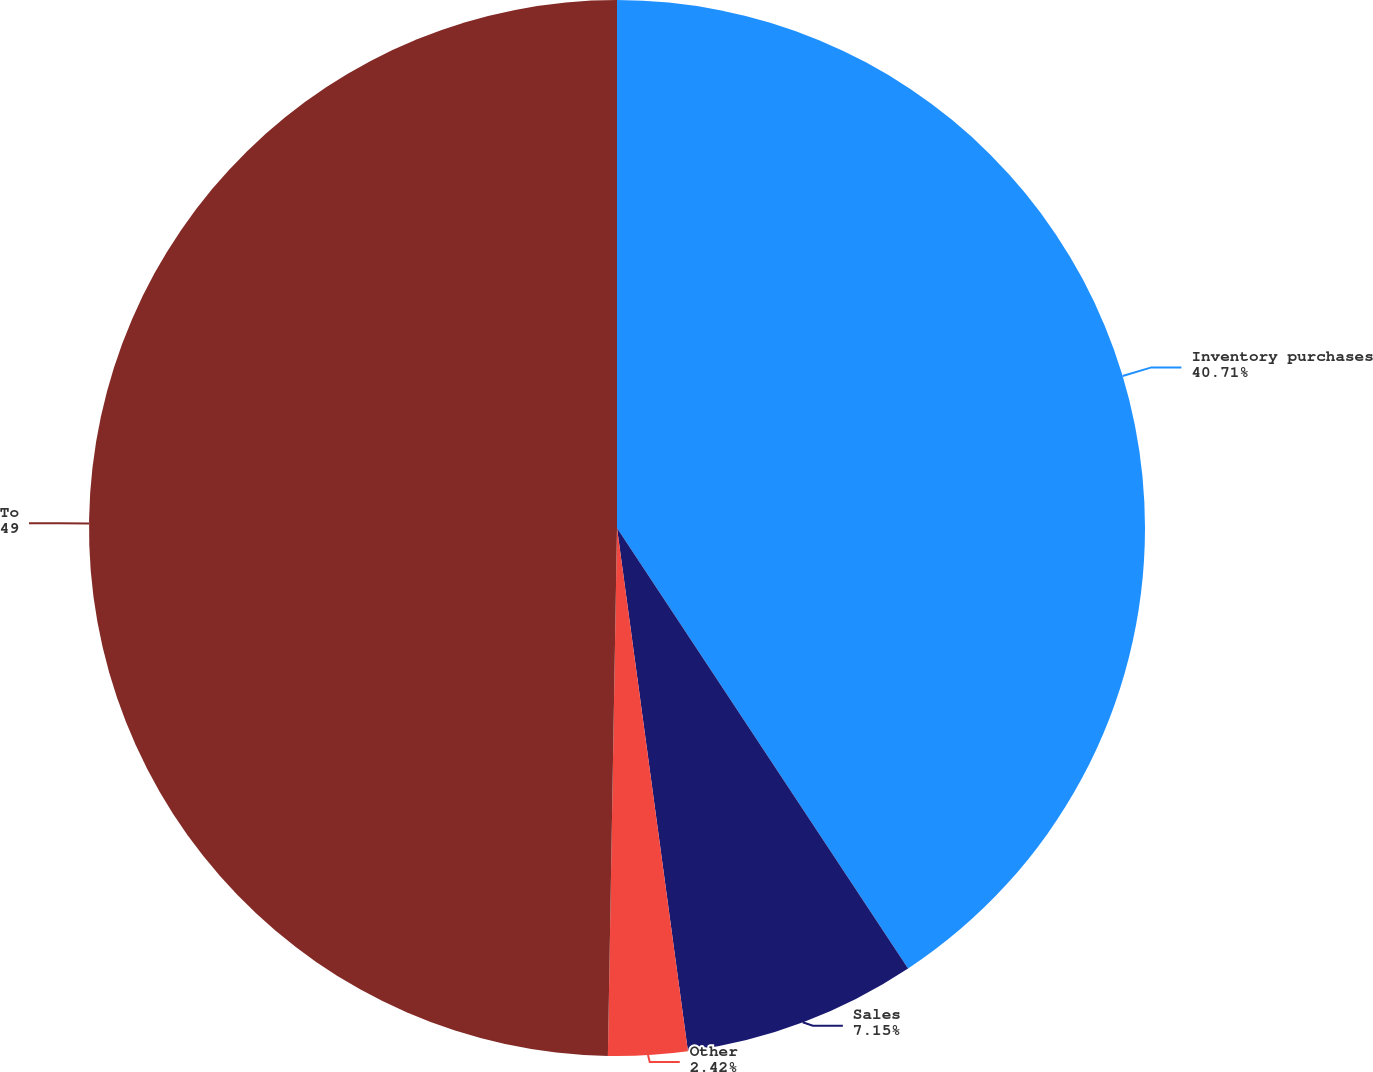Convert chart. <chart><loc_0><loc_0><loc_500><loc_500><pie_chart><fcel>Inventory purchases<fcel>Sales<fcel>Other<fcel>Total<nl><fcel>40.71%<fcel>7.15%<fcel>2.42%<fcel>49.73%<nl></chart> 